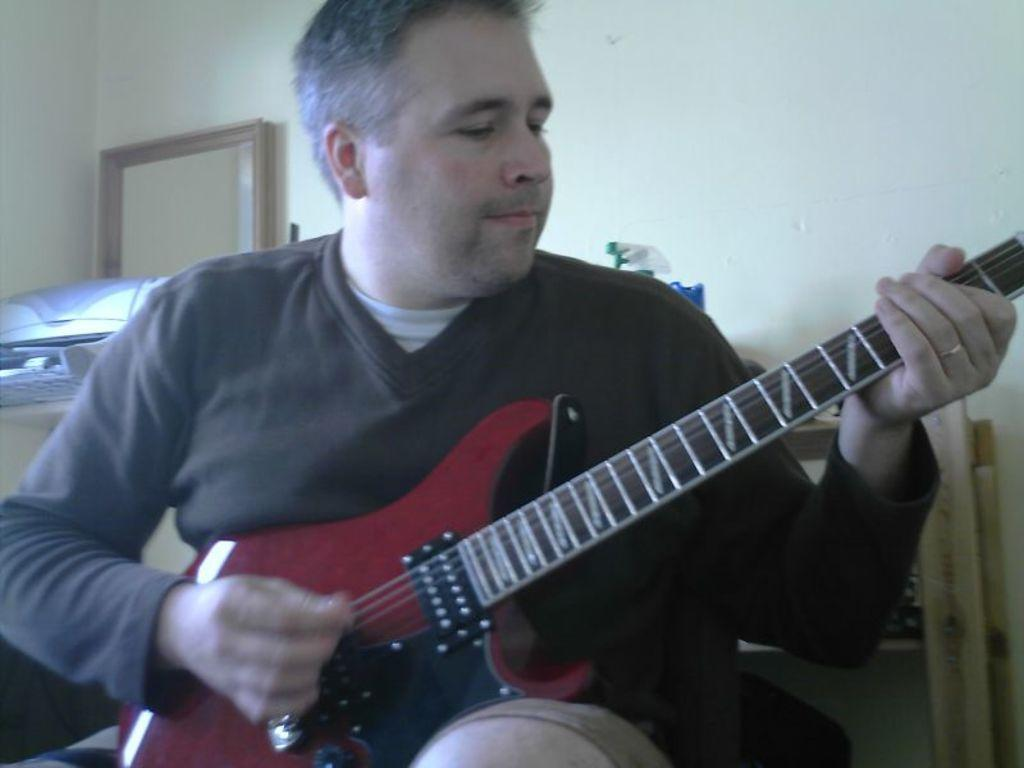What is the person in the image doing? The person is playing a guitar. What can be seen in the background of the image? There is a wall, a mirror, and shelves in the background of the image. What is on the shelves in the image? There are objects visible on the shelves. Where might this image have been taken? The image is likely taken in a room. What type of fuel is being used by the pot in the image? There is no pot or fuel present in the image. What show is the person in the image attending? There is no indication in the image that the person is attending a show. 